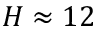Convert formula to latex. <formula><loc_0><loc_0><loc_500><loc_500>H \approx 1 2</formula> 